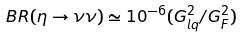<formula> <loc_0><loc_0><loc_500><loc_500>B R ( \eta \to \nu \nu ) \simeq 1 0 ^ { - 6 } ( G ^ { 2 } _ { l q } / G ^ { 2 } _ { F } )</formula> 